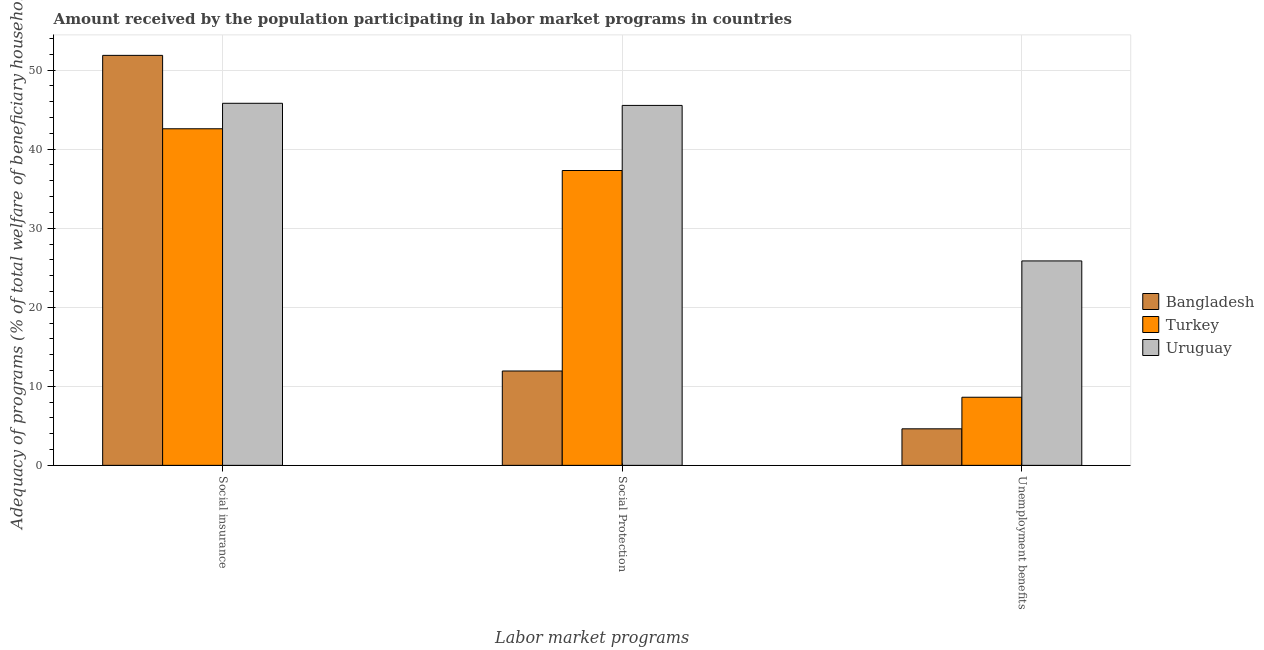How many different coloured bars are there?
Your response must be concise. 3. Are the number of bars per tick equal to the number of legend labels?
Your answer should be very brief. Yes. How many bars are there on the 1st tick from the left?
Provide a short and direct response. 3. How many bars are there on the 1st tick from the right?
Offer a very short reply. 3. What is the label of the 1st group of bars from the left?
Your response must be concise. Social insurance. What is the amount received by the population participating in social insurance programs in Uruguay?
Your answer should be very brief. 45.8. Across all countries, what is the maximum amount received by the population participating in social protection programs?
Give a very brief answer. 45.53. Across all countries, what is the minimum amount received by the population participating in social insurance programs?
Give a very brief answer. 42.58. What is the total amount received by the population participating in social insurance programs in the graph?
Make the answer very short. 140.24. What is the difference between the amount received by the population participating in unemployment benefits programs in Uruguay and that in Bangladesh?
Your response must be concise. 21.24. What is the difference between the amount received by the population participating in unemployment benefits programs in Turkey and the amount received by the population participating in social protection programs in Uruguay?
Offer a very short reply. -36.92. What is the average amount received by the population participating in social insurance programs per country?
Give a very brief answer. 46.75. What is the difference between the amount received by the population participating in social insurance programs and amount received by the population participating in social protection programs in Turkey?
Give a very brief answer. 5.28. In how many countries, is the amount received by the population participating in social protection programs greater than 10 %?
Your answer should be compact. 3. What is the ratio of the amount received by the population participating in unemployment benefits programs in Turkey to that in Bangladesh?
Give a very brief answer. 1.86. What is the difference between the highest and the second highest amount received by the population participating in unemployment benefits programs?
Your answer should be compact. 17.24. What is the difference between the highest and the lowest amount received by the population participating in social insurance programs?
Keep it short and to the point. 9.28. What does the 3rd bar from the left in Social Protection represents?
Your answer should be very brief. Uruguay. What does the 2nd bar from the right in Social Protection represents?
Make the answer very short. Turkey. Is it the case that in every country, the sum of the amount received by the population participating in social insurance programs and amount received by the population participating in social protection programs is greater than the amount received by the population participating in unemployment benefits programs?
Provide a short and direct response. Yes. Are all the bars in the graph horizontal?
Your answer should be very brief. No. How many countries are there in the graph?
Give a very brief answer. 3. Are the values on the major ticks of Y-axis written in scientific E-notation?
Offer a very short reply. No. Does the graph contain any zero values?
Provide a short and direct response. No. Does the graph contain grids?
Provide a succinct answer. Yes. What is the title of the graph?
Keep it short and to the point. Amount received by the population participating in labor market programs in countries. What is the label or title of the X-axis?
Your response must be concise. Labor market programs. What is the label or title of the Y-axis?
Your answer should be compact. Adequacy of programs (% of total welfare of beneficiary households). What is the Adequacy of programs (% of total welfare of beneficiary households) of Bangladesh in Social insurance?
Ensure brevity in your answer.  51.86. What is the Adequacy of programs (% of total welfare of beneficiary households) in Turkey in Social insurance?
Make the answer very short. 42.58. What is the Adequacy of programs (% of total welfare of beneficiary households) in Uruguay in Social insurance?
Offer a very short reply. 45.8. What is the Adequacy of programs (% of total welfare of beneficiary households) in Bangladesh in Social Protection?
Provide a succinct answer. 11.94. What is the Adequacy of programs (% of total welfare of beneficiary households) in Turkey in Social Protection?
Make the answer very short. 37.3. What is the Adequacy of programs (% of total welfare of beneficiary households) of Uruguay in Social Protection?
Provide a short and direct response. 45.53. What is the Adequacy of programs (% of total welfare of beneficiary households) of Bangladesh in Unemployment benefits?
Offer a terse response. 4.62. What is the Adequacy of programs (% of total welfare of beneficiary households) of Turkey in Unemployment benefits?
Your answer should be compact. 8.62. What is the Adequacy of programs (% of total welfare of beneficiary households) of Uruguay in Unemployment benefits?
Your answer should be compact. 25.86. Across all Labor market programs, what is the maximum Adequacy of programs (% of total welfare of beneficiary households) of Bangladesh?
Make the answer very short. 51.86. Across all Labor market programs, what is the maximum Adequacy of programs (% of total welfare of beneficiary households) of Turkey?
Make the answer very short. 42.58. Across all Labor market programs, what is the maximum Adequacy of programs (% of total welfare of beneficiary households) of Uruguay?
Offer a very short reply. 45.8. Across all Labor market programs, what is the minimum Adequacy of programs (% of total welfare of beneficiary households) of Bangladesh?
Offer a terse response. 4.62. Across all Labor market programs, what is the minimum Adequacy of programs (% of total welfare of beneficiary households) of Turkey?
Offer a terse response. 8.62. Across all Labor market programs, what is the minimum Adequacy of programs (% of total welfare of beneficiary households) of Uruguay?
Make the answer very short. 25.86. What is the total Adequacy of programs (% of total welfare of beneficiary households) of Bangladesh in the graph?
Make the answer very short. 68.42. What is the total Adequacy of programs (% of total welfare of beneficiary households) in Turkey in the graph?
Offer a very short reply. 88.49. What is the total Adequacy of programs (% of total welfare of beneficiary households) of Uruguay in the graph?
Ensure brevity in your answer.  117.19. What is the difference between the Adequacy of programs (% of total welfare of beneficiary households) of Bangladesh in Social insurance and that in Social Protection?
Your response must be concise. 39.92. What is the difference between the Adequacy of programs (% of total welfare of beneficiary households) of Turkey in Social insurance and that in Social Protection?
Your response must be concise. 5.28. What is the difference between the Adequacy of programs (% of total welfare of beneficiary households) of Uruguay in Social insurance and that in Social Protection?
Provide a short and direct response. 0.27. What is the difference between the Adequacy of programs (% of total welfare of beneficiary households) in Bangladesh in Social insurance and that in Unemployment benefits?
Keep it short and to the point. 47.24. What is the difference between the Adequacy of programs (% of total welfare of beneficiary households) of Turkey in Social insurance and that in Unemployment benefits?
Your answer should be compact. 33.96. What is the difference between the Adequacy of programs (% of total welfare of beneficiary households) in Uruguay in Social insurance and that in Unemployment benefits?
Your answer should be compact. 19.94. What is the difference between the Adequacy of programs (% of total welfare of beneficiary households) of Bangladesh in Social Protection and that in Unemployment benefits?
Offer a very short reply. 7.32. What is the difference between the Adequacy of programs (% of total welfare of beneficiary households) of Turkey in Social Protection and that in Unemployment benefits?
Ensure brevity in your answer.  28.68. What is the difference between the Adequacy of programs (% of total welfare of beneficiary households) in Uruguay in Social Protection and that in Unemployment benefits?
Your response must be concise. 19.67. What is the difference between the Adequacy of programs (% of total welfare of beneficiary households) in Bangladesh in Social insurance and the Adequacy of programs (% of total welfare of beneficiary households) in Turkey in Social Protection?
Give a very brief answer. 14.56. What is the difference between the Adequacy of programs (% of total welfare of beneficiary households) in Bangladesh in Social insurance and the Adequacy of programs (% of total welfare of beneficiary households) in Uruguay in Social Protection?
Your answer should be very brief. 6.33. What is the difference between the Adequacy of programs (% of total welfare of beneficiary households) in Turkey in Social insurance and the Adequacy of programs (% of total welfare of beneficiary households) in Uruguay in Social Protection?
Offer a very short reply. -2.95. What is the difference between the Adequacy of programs (% of total welfare of beneficiary households) of Bangladesh in Social insurance and the Adequacy of programs (% of total welfare of beneficiary households) of Turkey in Unemployment benefits?
Provide a short and direct response. 43.24. What is the difference between the Adequacy of programs (% of total welfare of beneficiary households) in Bangladesh in Social insurance and the Adequacy of programs (% of total welfare of beneficiary households) in Uruguay in Unemployment benefits?
Keep it short and to the point. 26. What is the difference between the Adequacy of programs (% of total welfare of beneficiary households) in Turkey in Social insurance and the Adequacy of programs (% of total welfare of beneficiary households) in Uruguay in Unemployment benefits?
Provide a succinct answer. 16.72. What is the difference between the Adequacy of programs (% of total welfare of beneficiary households) of Bangladesh in Social Protection and the Adequacy of programs (% of total welfare of beneficiary households) of Turkey in Unemployment benefits?
Your answer should be very brief. 3.32. What is the difference between the Adequacy of programs (% of total welfare of beneficiary households) in Bangladesh in Social Protection and the Adequacy of programs (% of total welfare of beneficiary households) in Uruguay in Unemployment benefits?
Your response must be concise. -13.92. What is the difference between the Adequacy of programs (% of total welfare of beneficiary households) in Turkey in Social Protection and the Adequacy of programs (% of total welfare of beneficiary households) in Uruguay in Unemployment benefits?
Your response must be concise. 11.44. What is the average Adequacy of programs (% of total welfare of beneficiary households) in Bangladesh per Labor market programs?
Your response must be concise. 22.81. What is the average Adequacy of programs (% of total welfare of beneficiary households) of Turkey per Labor market programs?
Offer a terse response. 29.5. What is the average Adequacy of programs (% of total welfare of beneficiary households) of Uruguay per Labor market programs?
Provide a succinct answer. 39.06. What is the difference between the Adequacy of programs (% of total welfare of beneficiary households) in Bangladesh and Adequacy of programs (% of total welfare of beneficiary households) in Turkey in Social insurance?
Keep it short and to the point. 9.28. What is the difference between the Adequacy of programs (% of total welfare of beneficiary households) of Bangladesh and Adequacy of programs (% of total welfare of beneficiary households) of Uruguay in Social insurance?
Your answer should be compact. 6.06. What is the difference between the Adequacy of programs (% of total welfare of beneficiary households) in Turkey and Adequacy of programs (% of total welfare of beneficiary households) in Uruguay in Social insurance?
Your answer should be very brief. -3.22. What is the difference between the Adequacy of programs (% of total welfare of beneficiary households) of Bangladesh and Adequacy of programs (% of total welfare of beneficiary households) of Turkey in Social Protection?
Offer a terse response. -25.36. What is the difference between the Adequacy of programs (% of total welfare of beneficiary households) of Bangladesh and Adequacy of programs (% of total welfare of beneficiary households) of Uruguay in Social Protection?
Provide a succinct answer. -33.6. What is the difference between the Adequacy of programs (% of total welfare of beneficiary households) in Turkey and Adequacy of programs (% of total welfare of beneficiary households) in Uruguay in Social Protection?
Give a very brief answer. -8.23. What is the difference between the Adequacy of programs (% of total welfare of beneficiary households) in Bangladesh and Adequacy of programs (% of total welfare of beneficiary households) in Turkey in Unemployment benefits?
Your answer should be very brief. -4. What is the difference between the Adequacy of programs (% of total welfare of beneficiary households) of Bangladesh and Adequacy of programs (% of total welfare of beneficiary households) of Uruguay in Unemployment benefits?
Ensure brevity in your answer.  -21.24. What is the difference between the Adequacy of programs (% of total welfare of beneficiary households) of Turkey and Adequacy of programs (% of total welfare of beneficiary households) of Uruguay in Unemployment benefits?
Offer a terse response. -17.24. What is the ratio of the Adequacy of programs (% of total welfare of beneficiary households) of Bangladesh in Social insurance to that in Social Protection?
Ensure brevity in your answer.  4.34. What is the ratio of the Adequacy of programs (% of total welfare of beneficiary households) of Turkey in Social insurance to that in Social Protection?
Your answer should be compact. 1.14. What is the ratio of the Adequacy of programs (% of total welfare of beneficiary households) of Uruguay in Social insurance to that in Social Protection?
Your response must be concise. 1.01. What is the ratio of the Adequacy of programs (% of total welfare of beneficiary households) in Bangladesh in Social insurance to that in Unemployment benefits?
Offer a very short reply. 11.22. What is the ratio of the Adequacy of programs (% of total welfare of beneficiary households) in Turkey in Social insurance to that in Unemployment benefits?
Offer a terse response. 4.94. What is the ratio of the Adequacy of programs (% of total welfare of beneficiary households) of Uruguay in Social insurance to that in Unemployment benefits?
Your answer should be compact. 1.77. What is the ratio of the Adequacy of programs (% of total welfare of beneficiary households) of Bangladesh in Social Protection to that in Unemployment benefits?
Your response must be concise. 2.58. What is the ratio of the Adequacy of programs (% of total welfare of beneficiary households) of Turkey in Social Protection to that in Unemployment benefits?
Offer a very short reply. 4.33. What is the ratio of the Adequacy of programs (% of total welfare of beneficiary households) of Uruguay in Social Protection to that in Unemployment benefits?
Your answer should be very brief. 1.76. What is the difference between the highest and the second highest Adequacy of programs (% of total welfare of beneficiary households) of Bangladesh?
Make the answer very short. 39.92. What is the difference between the highest and the second highest Adequacy of programs (% of total welfare of beneficiary households) of Turkey?
Provide a succinct answer. 5.28. What is the difference between the highest and the second highest Adequacy of programs (% of total welfare of beneficiary households) in Uruguay?
Keep it short and to the point. 0.27. What is the difference between the highest and the lowest Adequacy of programs (% of total welfare of beneficiary households) of Bangladesh?
Provide a succinct answer. 47.24. What is the difference between the highest and the lowest Adequacy of programs (% of total welfare of beneficiary households) in Turkey?
Keep it short and to the point. 33.96. What is the difference between the highest and the lowest Adequacy of programs (% of total welfare of beneficiary households) of Uruguay?
Your response must be concise. 19.94. 